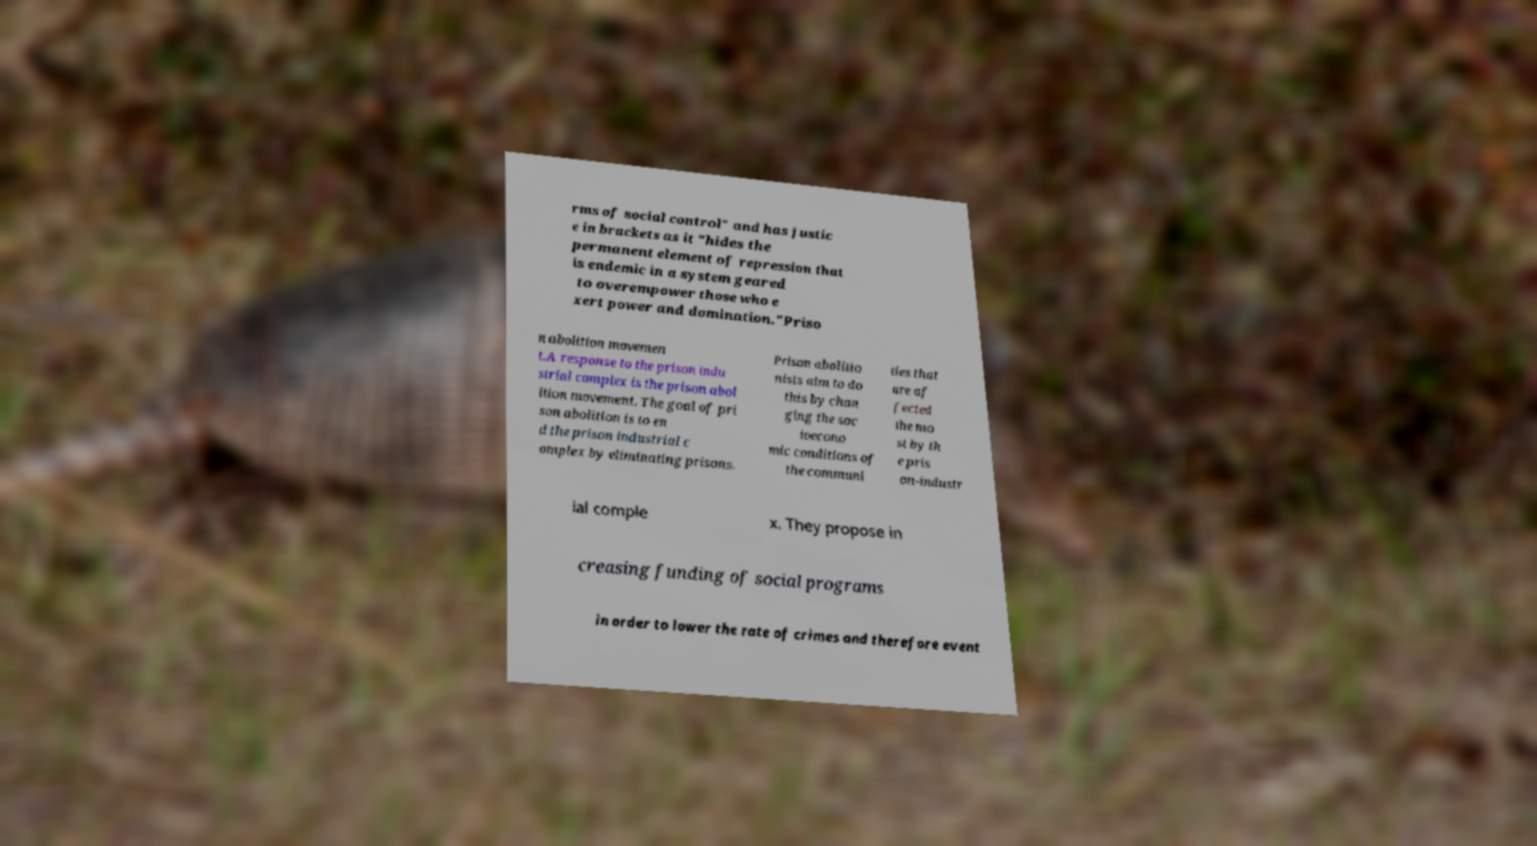For documentation purposes, I need the text within this image transcribed. Could you provide that? rms of social control" and has justic e in brackets as it "hides the permanent element of repression that is endemic in a system geared to overempower those who e xert power and domination."Priso n abolition movemen t.A response to the prison indu strial complex is the prison abol ition movement. The goal of pri son abolition is to en d the prison industrial c omplex by eliminating prisons. Prison abolitio nists aim to do this by chan ging the soc ioecono mic conditions of the communi ties that are af fected the mo st by th e pris on-industr ial comple x. They propose in creasing funding of social programs in order to lower the rate of crimes and therefore event 